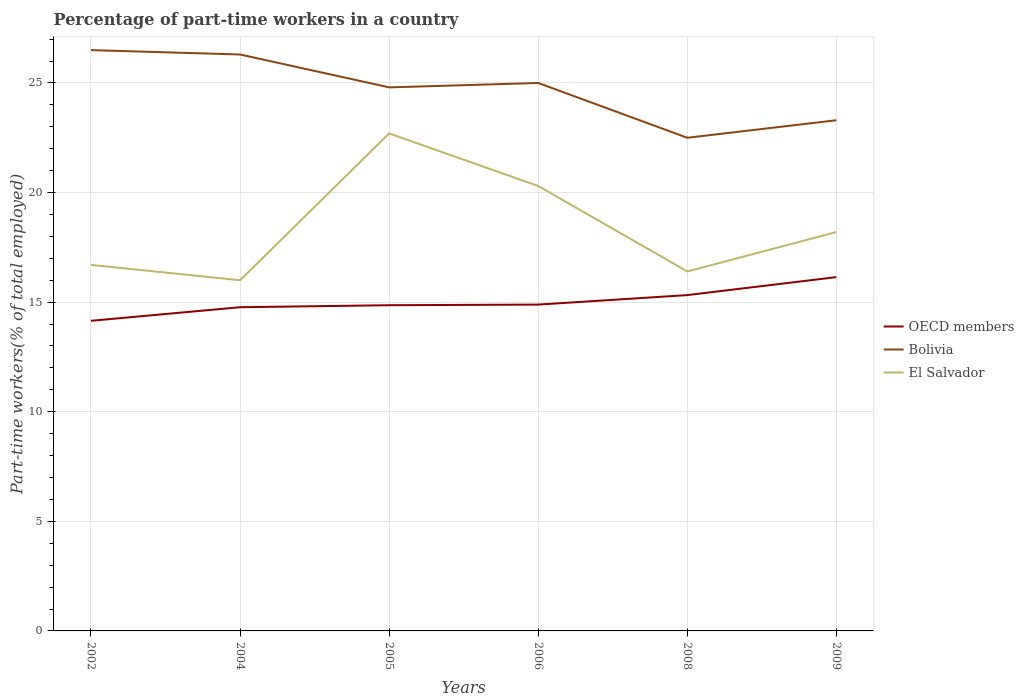Does the line corresponding to El Salvador intersect with the line corresponding to Bolivia?
Offer a terse response. No. Across all years, what is the maximum percentage of part-time workers in El Salvador?
Offer a very short reply. 16. What is the total percentage of part-time workers in OECD members in the graph?
Provide a succinct answer. -0.55. What is the difference between the highest and the second highest percentage of part-time workers in El Salvador?
Offer a terse response. 6.7. What is the difference between the highest and the lowest percentage of part-time workers in El Salvador?
Your answer should be very brief. 2. Is the percentage of part-time workers in OECD members strictly greater than the percentage of part-time workers in Bolivia over the years?
Your answer should be very brief. Yes. How many years are there in the graph?
Your answer should be very brief. 6. Are the values on the major ticks of Y-axis written in scientific E-notation?
Offer a terse response. No. Does the graph contain any zero values?
Keep it short and to the point. No. Where does the legend appear in the graph?
Your answer should be very brief. Center right. What is the title of the graph?
Your answer should be compact. Percentage of part-time workers in a country. What is the label or title of the Y-axis?
Ensure brevity in your answer.  Part-time workers(% of total employed). What is the Part-time workers(% of total employed) of OECD members in 2002?
Your answer should be compact. 14.15. What is the Part-time workers(% of total employed) in El Salvador in 2002?
Offer a terse response. 16.7. What is the Part-time workers(% of total employed) in OECD members in 2004?
Offer a terse response. 14.77. What is the Part-time workers(% of total employed) in Bolivia in 2004?
Provide a succinct answer. 26.3. What is the Part-time workers(% of total employed) in El Salvador in 2004?
Ensure brevity in your answer.  16. What is the Part-time workers(% of total employed) of OECD members in 2005?
Give a very brief answer. 14.86. What is the Part-time workers(% of total employed) in Bolivia in 2005?
Your answer should be very brief. 24.8. What is the Part-time workers(% of total employed) of El Salvador in 2005?
Your answer should be very brief. 22.7. What is the Part-time workers(% of total employed) of OECD members in 2006?
Keep it short and to the point. 14.89. What is the Part-time workers(% of total employed) in Bolivia in 2006?
Ensure brevity in your answer.  25. What is the Part-time workers(% of total employed) of El Salvador in 2006?
Keep it short and to the point. 20.3. What is the Part-time workers(% of total employed) in OECD members in 2008?
Ensure brevity in your answer.  15.32. What is the Part-time workers(% of total employed) in El Salvador in 2008?
Make the answer very short. 16.4. What is the Part-time workers(% of total employed) in OECD members in 2009?
Your answer should be very brief. 16.14. What is the Part-time workers(% of total employed) of Bolivia in 2009?
Offer a very short reply. 23.3. What is the Part-time workers(% of total employed) of El Salvador in 2009?
Offer a terse response. 18.2. Across all years, what is the maximum Part-time workers(% of total employed) in OECD members?
Make the answer very short. 16.14. Across all years, what is the maximum Part-time workers(% of total employed) in El Salvador?
Your answer should be compact. 22.7. Across all years, what is the minimum Part-time workers(% of total employed) of OECD members?
Your answer should be compact. 14.15. Across all years, what is the minimum Part-time workers(% of total employed) of El Salvador?
Your answer should be very brief. 16. What is the total Part-time workers(% of total employed) in OECD members in the graph?
Ensure brevity in your answer.  90.13. What is the total Part-time workers(% of total employed) in Bolivia in the graph?
Offer a terse response. 148.4. What is the total Part-time workers(% of total employed) in El Salvador in the graph?
Your answer should be very brief. 110.3. What is the difference between the Part-time workers(% of total employed) of OECD members in 2002 and that in 2004?
Provide a short and direct response. -0.62. What is the difference between the Part-time workers(% of total employed) of OECD members in 2002 and that in 2005?
Provide a short and direct response. -0.71. What is the difference between the Part-time workers(% of total employed) in Bolivia in 2002 and that in 2005?
Your response must be concise. 1.7. What is the difference between the Part-time workers(% of total employed) in OECD members in 2002 and that in 2006?
Keep it short and to the point. -0.74. What is the difference between the Part-time workers(% of total employed) of Bolivia in 2002 and that in 2006?
Your answer should be compact. 1.5. What is the difference between the Part-time workers(% of total employed) of OECD members in 2002 and that in 2008?
Your answer should be very brief. -1.17. What is the difference between the Part-time workers(% of total employed) of Bolivia in 2002 and that in 2008?
Your response must be concise. 4. What is the difference between the Part-time workers(% of total employed) in OECD members in 2002 and that in 2009?
Ensure brevity in your answer.  -1.99. What is the difference between the Part-time workers(% of total employed) in Bolivia in 2002 and that in 2009?
Provide a succinct answer. 3.2. What is the difference between the Part-time workers(% of total employed) in OECD members in 2004 and that in 2005?
Provide a succinct answer. -0.09. What is the difference between the Part-time workers(% of total employed) of El Salvador in 2004 and that in 2005?
Your answer should be compact. -6.7. What is the difference between the Part-time workers(% of total employed) of OECD members in 2004 and that in 2006?
Keep it short and to the point. -0.12. What is the difference between the Part-time workers(% of total employed) of Bolivia in 2004 and that in 2006?
Offer a very short reply. 1.3. What is the difference between the Part-time workers(% of total employed) of OECD members in 2004 and that in 2008?
Your answer should be very brief. -0.55. What is the difference between the Part-time workers(% of total employed) in OECD members in 2004 and that in 2009?
Ensure brevity in your answer.  -1.37. What is the difference between the Part-time workers(% of total employed) of Bolivia in 2004 and that in 2009?
Offer a very short reply. 3. What is the difference between the Part-time workers(% of total employed) of El Salvador in 2004 and that in 2009?
Keep it short and to the point. -2.2. What is the difference between the Part-time workers(% of total employed) in OECD members in 2005 and that in 2006?
Your answer should be compact. -0.03. What is the difference between the Part-time workers(% of total employed) of Bolivia in 2005 and that in 2006?
Ensure brevity in your answer.  -0.2. What is the difference between the Part-time workers(% of total employed) in OECD members in 2005 and that in 2008?
Your response must be concise. -0.46. What is the difference between the Part-time workers(% of total employed) in El Salvador in 2005 and that in 2008?
Offer a very short reply. 6.3. What is the difference between the Part-time workers(% of total employed) in OECD members in 2005 and that in 2009?
Your response must be concise. -1.28. What is the difference between the Part-time workers(% of total employed) of OECD members in 2006 and that in 2008?
Your response must be concise. -0.43. What is the difference between the Part-time workers(% of total employed) of Bolivia in 2006 and that in 2008?
Give a very brief answer. 2.5. What is the difference between the Part-time workers(% of total employed) in OECD members in 2006 and that in 2009?
Your response must be concise. -1.25. What is the difference between the Part-time workers(% of total employed) of Bolivia in 2006 and that in 2009?
Keep it short and to the point. 1.7. What is the difference between the Part-time workers(% of total employed) of OECD members in 2008 and that in 2009?
Offer a very short reply. -0.82. What is the difference between the Part-time workers(% of total employed) of Bolivia in 2008 and that in 2009?
Give a very brief answer. -0.8. What is the difference between the Part-time workers(% of total employed) in OECD members in 2002 and the Part-time workers(% of total employed) in Bolivia in 2004?
Offer a terse response. -12.15. What is the difference between the Part-time workers(% of total employed) in OECD members in 2002 and the Part-time workers(% of total employed) in El Salvador in 2004?
Your answer should be very brief. -1.85. What is the difference between the Part-time workers(% of total employed) in Bolivia in 2002 and the Part-time workers(% of total employed) in El Salvador in 2004?
Your response must be concise. 10.5. What is the difference between the Part-time workers(% of total employed) in OECD members in 2002 and the Part-time workers(% of total employed) in Bolivia in 2005?
Offer a very short reply. -10.65. What is the difference between the Part-time workers(% of total employed) of OECD members in 2002 and the Part-time workers(% of total employed) of El Salvador in 2005?
Give a very brief answer. -8.55. What is the difference between the Part-time workers(% of total employed) in Bolivia in 2002 and the Part-time workers(% of total employed) in El Salvador in 2005?
Offer a terse response. 3.8. What is the difference between the Part-time workers(% of total employed) in OECD members in 2002 and the Part-time workers(% of total employed) in Bolivia in 2006?
Offer a very short reply. -10.85. What is the difference between the Part-time workers(% of total employed) in OECD members in 2002 and the Part-time workers(% of total employed) in El Salvador in 2006?
Make the answer very short. -6.15. What is the difference between the Part-time workers(% of total employed) in OECD members in 2002 and the Part-time workers(% of total employed) in Bolivia in 2008?
Your response must be concise. -8.35. What is the difference between the Part-time workers(% of total employed) in OECD members in 2002 and the Part-time workers(% of total employed) in El Salvador in 2008?
Provide a succinct answer. -2.25. What is the difference between the Part-time workers(% of total employed) in Bolivia in 2002 and the Part-time workers(% of total employed) in El Salvador in 2008?
Offer a terse response. 10.1. What is the difference between the Part-time workers(% of total employed) of OECD members in 2002 and the Part-time workers(% of total employed) of Bolivia in 2009?
Offer a terse response. -9.15. What is the difference between the Part-time workers(% of total employed) of OECD members in 2002 and the Part-time workers(% of total employed) of El Salvador in 2009?
Provide a succinct answer. -4.05. What is the difference between the Part-time workers(% of total employed) of Bolivia in 2002 and the Part-time workers(% of total employed) of El Salvador in 2009?
Give a very brief answer. 8.3. What is the difference between the Part-time workers(% of total employed) in OECD members in 2004 and the Part-time workers(% of total employed) in Bolivia in 2005?
Provide a short and direct response. -10.03. What is the difference between the Part-time workers(% of total employed) in OECD members in 2004 and the Part-time workers(% of total employed) in El Salvador in 2005?
Offer a very short reply. -7.93. What is the difference between the Part-time workers(% of total employed) in OECD members in 2004 and the Part-time workers(% of total employed) in Bolivia in 2006?
Your answer should be compact. -10.23. What is the difference between the Part-time workers(% of total employed) in OECD members in 2004 and the Part-time workers(% of total employed) in El Salvador in 2006?
Make the answer very short. -5.53. What is the difference between the Part-time workers(% of total employed) of Bolivia in 2004 and the Part-time workers(% of total employed) of El Salvador in 2006?
Provide a succinct answer. 6. What is the difference between the Part-time workers(% of total employed) of OECD members in 2004 and the Part-time workers(% of total employed) of Bolivia in 2008?
Provide a short and direct response. -7.73. What is the difference between the Part-time workers(% of total employed) in OECD members in 2004 and the Part-time workers(% of total employed) in El Salvador in 2008?
Offer a very short reply. -1.63. What is the difference between the Part-time workers(% of total employed) in Bolivia in 2004 and the Part-time workers(% of total employed) in El Salvador in 2008?
Provide a succinct answer. 9.9. What is the difference between the Part-time workers(% of total employed) of OECD members in 2004 and the Part-time workers(% of total employed) of Bolivia in 2009?
Offer a very short reply. -8.53. What is the difference between the Part-time workers(% of total employed) in OECD members in 2004 and the Part-time workers(% of total employed) in El Salvador in 2009?
Provide a succinct answer. -3.43. What is the difference between the Part-time workers(% of total employed) in OECD members in 2005 and the Part-time workers(% of total employed) in Bolivia in 2006?
Offer a terse response. -10.14. What is the difference between the Part-time workers(% of total employed) in OECD members in 2005 and the Part-time workers(% of total employed) in El Salvador in 2006?
Your response must be concise. -5.44. What is the difference between the Part-time workers(% of total employed) of OECD members in 2005 and the Part-time workers(% of total employed) of Bolivia in 2008?
Ensure brevity in your answer.  -7.64. What is the difference between the Part-time workers(% of total employed) in OECD members in 2005 and the Part-time workers(% of total employed) in El Salvador in 2008?
Make the answer very short. -1.54. What is the difference between the Part-time workers(% of total employed) in OECD members in 2005 and the Part-time workers(% of total employed) in Bolivia in 2009?
Ensure brevity in your answer.  -8.44. What is the difference between the Part-time workers(% of total employed) of OECD members in 2005 and the Part-time workers(% of total employed) of El Salvador in 2009?
Keep it short and to the point. -3.34. What is the difference between the Part-time workers(% of total employed) in Bolivia in 2005 and the Part-time workers(% of total employed) in El Salvador in 2009?
Offer a very short reply. 6.6. What is the difference between the Part-time workers(% of total employed) of OECD members in 2006 and the Part-time workers(% of total employed) of Bolivia in 2008?
Your answer should be very brief. -7.61. What is the difference between the Part-time workers(% of total employed) in OECD members in 2006 and the Part-time workers(% of total employed) in El Salvador in 2008?
Make the answer very short. -1.51. What is the difference between the Part-time workers(% of total employed) of Bolivia in 2006 and the Part-time workers(% of total employed) of El Salvador in 2008?
Make the answer very short. 8.6. What is the difference between the Part-time workers(% of total employed) in OECD members in 2006 and the Part-time workers(% of total employed) in Bolivia in 2009?
Your response must be concise. -8.41. What is the difference between the Part-time workers(% of total employed) of OECD members in 2006 and the Part-time workers(% of total employed) of El Salvador in 2009?
Provide a short and direct response. -3.31. What is the difference between the Part-time workers(% of total employed) of OECD members in 2008 and the Part-time workers(% of total employed) of Bolivia in 2009?
Offer a terse response. -7.98. What is the difference between the Part-time workers(% of total employed) in OECD members in 2008 and the Part-time workers(% of total employed) in El Salvador in 2009?
Provide a succinct answer. -2.88. What is the average Part-time workers(% of total employed) in OECD members per year?
Provide a short and direct response. 15.02. What is the average Part-time workers(% of total employed) of Bolivia per year?
Make the answer very short. 24.73. What is the average Part-time workers(% of total employed) of El Salvador per year?
Your response must be concise. 18.38. In the year 2002, what is the difference between the Part-time workers(% of total employed) in OECD members and Part-time workers(% of total employed) in Bolivia?
Offer a very short reply. -12.35. In the year 2002, what is the difference between the Part-time workers(% of total employed) in OECD members and Part-time workers(% of total employed) in El Salvador?
Make the answer very short. -2.55. In the year 2002, what is the difference between the Part-time workers(% of total employed) of Bolivia and Part-time workers(% of total employed) of El Salvador?
Offer a very short reply. 9.8. In the year 2004, what is the difference between the Part-time workers(% of total employed) in OECD members and Part-time workers(% of total employed) in Bolivia?
Give a very brief answer. -11.53. In the year 2004, what is the difference between the Part-time workers(% of total employed) in OECD members and Part-time workers(% of total employed) in El Salvador?
Your answer should be very brief. -1.23. In the year 2005, what is the difference between the Part-time workers(% of total employed) of OECD members and Part-time workers(% of total employed) of Bolivia?
Your answer should be very brief. -9.94. In the year 2005, what is the difference between the Part-time workers(% of total employed) in OECD members and Part-time workers(% of total employed) in El Salvador?
Provide a succinct answer. -7.84. In the year 2005, what is the difference between the Part-time workers(% of total employed) of Bolivia and Part-time workers(% of total employed) of El Salvador?
Offer a terse response. 2.1. In the year 2006, what is the difference between the Part-time workers(% of total employed) in OECD members and Part-time workers(% of total employed) in Bolivia?
Your answer should be compact. -10.11. In the year 2006, what is the difference between the Part-time workers(% of total employed) in OECD members and Part-time workers(% of total employed) in El Salvador?
Make the answer very short. -5.41. In the year 2006, what is the difference between the Part-time workers(% of total employed) of Bolivia and Part-time workers(% of total employed) of El Salvador?
Provide a short and direct response. 4.7. In the year 2008, what is the difference between the Part-time workers(% of total employed) of OECD members and Part-time workers(% of total employed) of Bolivia?
Provide a succinct answer. -7.18. In the year 2008, what is the difference between the Part-time workers(% of total employed) in OECD members and Part-time workers(% of total employed) in El Salvador?
Your answer should be very brief. -1.08. In the year 2008, what is the difference between the Part-time workers(% of total employed) of Bolivia and Part-time workers(% of total employed) of El Salvador?
Ensure brevity in your answer.  6.1. In the year 2009, what is the difference between the Part-time workers(% of total employed) in OECD members and Part-time workers(% of total employed) in Bolivia?
Keep it short and to the point. -7.16. In the year 2009, what is the difference between the Part-time workers(% of total employed) in OECD members and Part-time workers(% of total employed) in El Salvador?
Provide a succinct answer. -2.06. In the year 2009, what is the difference between the Part-time workers(% of total employed) of Bolivia and Part-time workers(% of total employed) of El Salvador?
Offer a very short reply. 5.1. What is the ratio of the Part-time workers(% of total employed) in OECD members in 2002 to that in 2004?
Your answer should be very brief. 0.96. What is the ratio of the Part-time workers(% of total employed) in Bolivia in 2002 to that in 2004?
Provide a short and direct response. 1.01. What is the ratio of the Part-time workers(% of total employed) of El Salvador in 2002 to that in 2004?
Your answer should be very brief. 1.04. What is the ratio of the Part-time workers(% of total employed) in OECD members in 2002 to that in 2005?
Provide a short and direct response. 0.95. What is the ratio of the Part-time workers(% of total employed) of Bolivia in 2002 to that in 2005?
Your answer should be very brief. 1.07. What is the ratio of the Part-time workers(% of total employed) in El Salvador in 2002 to that in 2005?
Give a very brief answer. 0.74. What is the ratio of the Part-time workers(% of total employed) of OECD members in 2002 to that in 2006?
Make the answer very short. 0.95. What is the ratio of the Part-time workers(% of total employed) of Bolivia in 2002 to that in 2006?
Your response must be concise. 1.06. What is the ratio of the Part-time workers(% of total employed) in El Salvador in 2002 to that in 2006?
Your response must be concise. 0.82. What is the ratio of the Part-time workers(% of total employed) in OECD members in 2002 to that in 2008?
Offer a very short reply. 0.92. What is the ratio of the Part-time workers(% of total employed) of Bolivia in 2002 to that in 2008?
Your answer should be very brief. 1.18. What is the ratio of the Part-time workers(% of total employed) in El Salvador in 2002 to that in 2008?
Ensure brevity in your answer.  1.02. What is the ratio of the Part-time workers(% of total employed) of OECD members in 2002 to that in 2009?
Offer a terse response. 0.88. What is the ratio of the Part-time workers(% of total employed) of Bolivia in 2002 to that in 2009?
Give a very brief answer. 1.14. What is the ratio of the Part-time workers(% of total employed) of El Salvador in 2002 to that in 2009?
Make the answer very short. 0.92. What is the ratio of the Part-time workers(% of total employed) in OECD members in 2004 to that in 2005?
Your response must be concise. 0.99. What is the ratio of the Part-time workers(% of total employed) in Bolivia in 2004 to that in 2005?
Keep it short and to the point. 1.06. What is the ratio of the Part-time workers(% of total employed) of El Salvador in 2004 to that in 2005?
Keep it short and to the point. 0.7. What is the ratio of the Part-time workers(% of total employed) in OECD members in 2004 to that in 2006?
Offer a very short reply. 0.99. What is the ratio of the Part-time workers(% of total employed) in Bolivia in 2004 to that in 2006?
Offer a very short reply. 1.05. What is the ratio of the Part-time workers(% of total employed) of El Salvador in 2004 to that in 2006?
Keep it short and to the point. 0.79. What is the ratio of the Part-time workers(% of total employed) of OECD members in 2004 to that in 2008?
Your answer should be compact. 0.96. What is the ratio of the Part-time workers(% of total employed) in Bolivia in 2004 to that in 2008?
Offer a terse response. 1.17. What is the ratio of the Part-time workers(% of total employed) of El Salvador in 2004 to that in 2008?
Offer a very short reply. 0.98. What is the ratio of the Part-time workers(% of total employed) in OECD members in 2004 to that in 2009?
Your answer should be compact. 0.91. What is the ratio of the Part-time workers(% of total employed) in Bolivia in 2004 to that in 2009?
Provide a succinct answer. 1.13. What is the ratio of the Part-time workers(% of total employed) in El Salvador in 2004 to that in 2009?
Keep it short and to the point. 0.88. What is the ratio of the Part-time workers(% of total employed) in OECD members in 2005 to that in 2006?
Keep it short and to the point. 1. What is the ratio of the Part-time workers(% of total employed) of El Salvador in 2005 to that in 2006?
Make the answer very short. 1.12. What is the ratio of the Part-time workers(% of total employed) of OECD members in 2005 to that in 2008?
Make the answer very short. 0.97. What is the ratio of the Part-time workers(% of total employed) in Bolivia in 2005 to that in 2008?
Your answer should be very brief. 1.1. What is the ratio of the Part-time workers(% of total employed) in El Salvador in 2005 to that in 2008?
Give a very brief answer. 1.38. What is the ratio of the Part-time workers(% of total employed) in OECD members in 2005 to that in 2009?
Make the answer very short. 0.92. What is the ratio of the Part-time workers(% of total employed) in Bolivia in 2005 to that in 2009?
Your answer should be very brief. 1.06. What is the ratio of the Part-time workers(% of total employed) of El Salvador in 2005 to that in 2009?
Offer a terse response. 1.25. What is the ratio of the Part-time workers(% of total employed) in OECD members in 2006 to that in 2008?
Provide a succinct answer. 0.97. What is the ratio of the Part-time workers(% of total employed) in El Salvador in 2006 to that in 2008?
Provide a succinct answer. 1.24. What is the ratio of the Part-time workers(% of total employed) in OECD members in 2006 to that in 2009?
Give a very brief answer. 0.92. What is the ratio of the Part-time workers(% of total employed) in Bolivia in 2006 to that in 2009?
Keep it short and to the point. 1.07. What is the ratio of the Part-time workers(% of total employed) in El Salvador in 2006 to that in 2009?
Keep it short and to the point. 1.12. What is the ratio of the Part-time workers(% of total employed) of OECD members in 2008 to that in 2009?
Give a very brief answer. 0.95. What is the ratio of the Part-time workers(% of total employed) in Bolivia in 2008 to that in 2009?
Make the answer very short. 0.97. What is the ratio of the Part-time workers(% of total employed) of El Salvador in 2008 to that in 2009?
Provide a succinct answer. 0.9. What is the difference between the highest and the second highest Part-time workers(% of total employed) of OECD members?
Your answer should be compact. 0.82. What is the difference between the highest and the second highest Part-time workers(% of total employed) of El Salvador?
Give a very brief answer. 2.4. What is the difference between the highest and the lowest Part-time workers(% of total employed) in OECD members?
Your answer should be very brief. 1.99. 